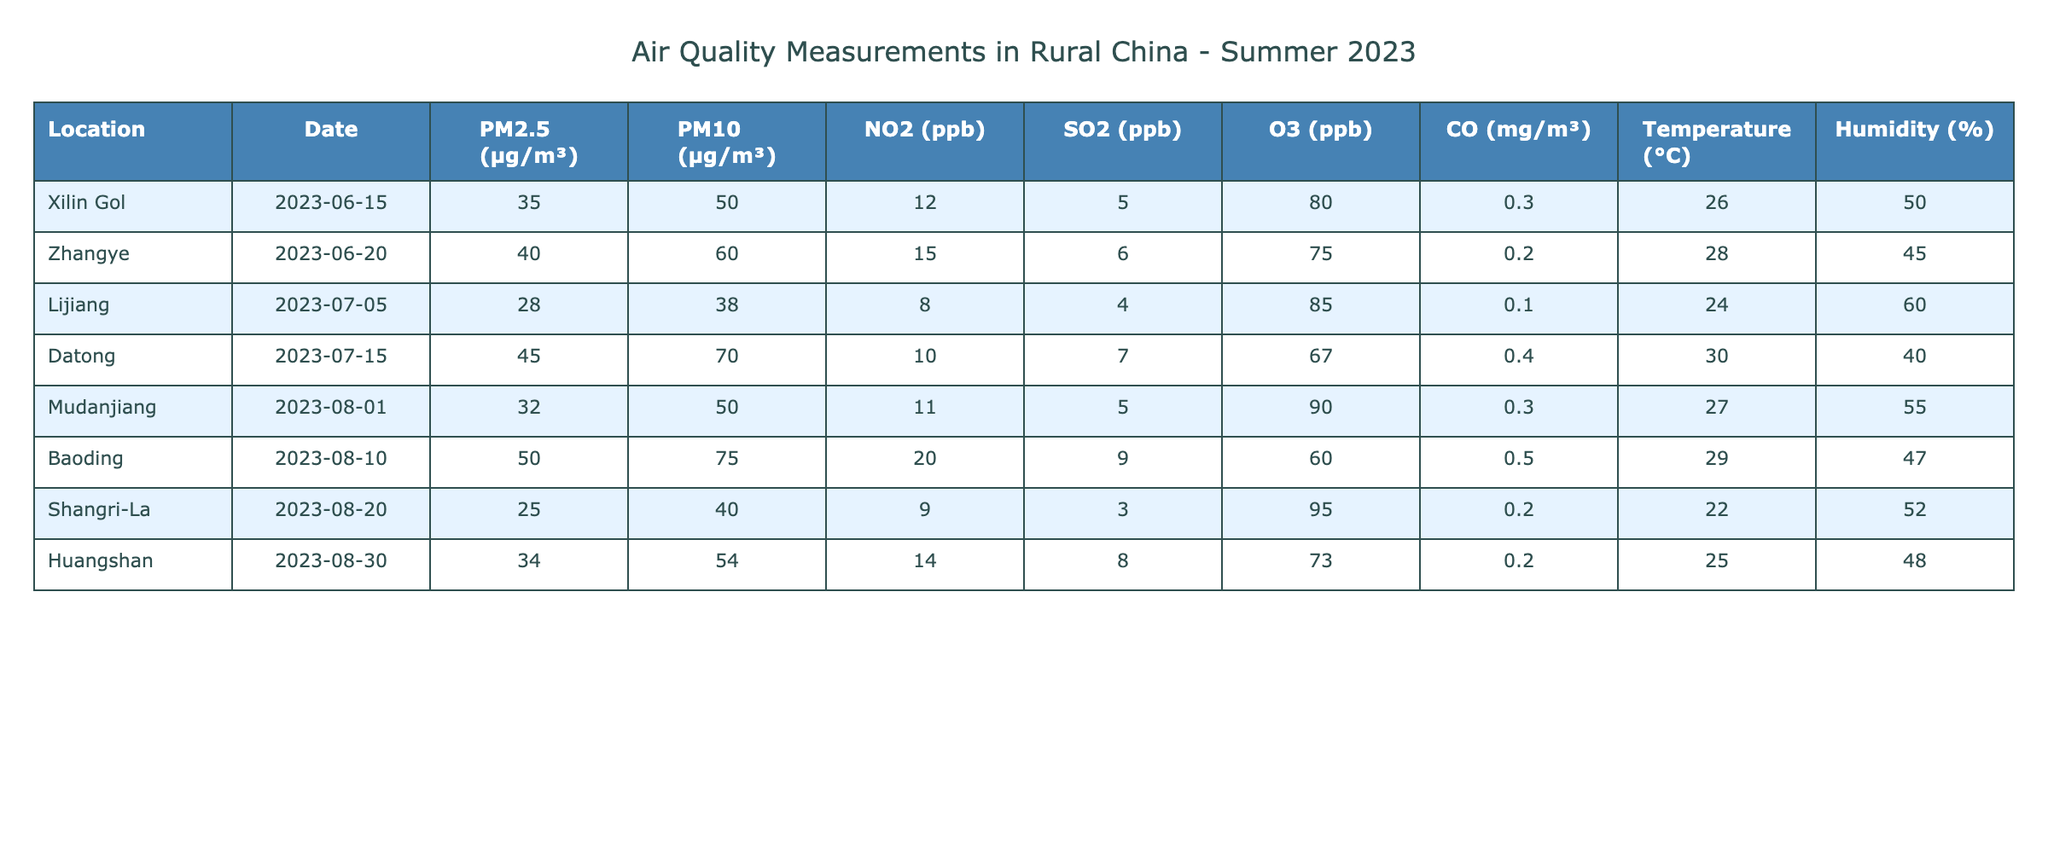What is the PM2.5 level recorded in Baoding on August 10, 2023? The table indicates that Baoding has a PM2.5 level of 50 µg/m³ on the mentioned date. This information is directly referenced in the corresponding row under the PM2.5 column.
Answer: 50 µg/m³ Which location recorded the highest level of NO2? By examining the NO2 values across all locations, Baoding on August 10, 2023, shows the highest level at 20 ppb. This is determined by comparing each NO2 value listed in the table.
Answer: Baoding What is the average SO2 level for the locations listed? The SO2 levels are 5, 6, 4, 7, 5, 9, 3, and 8 for the respective locations. Adding these values gives a total of 43. There are 8 data points, so the average is calculated as 43/8 = 5.375.
Answer: 5.375 ppb Is the humidity level in Zhangye higher than that in Datong? Zhangye's humidity is 45%, while Datong's is 40%. Since 45% is greater than 40%, the statement is true. This is confirmed by comparing respective humidity values in the table.
Answer: Yes What is the difference in PM10 levels between the highest and lowest recorded values? The highest PM10 level is in Baoding with 75 µg/m³, and the lowest is in Lijiang with 38 µg/m³. The difference is calculated as 75 - 38 = 37 µg/m³. Thus, this represents the gap in PM10 levels across locations.
Answer: 37 µg/m³ What is the temperature recorded in Mudanjiang on August 1, 2023? According to the table, Mudanjiang has a temperature of 27°C for the stated date. This can be confirmed directly from the temperature column corresponding to Mudanjiang's row in the table.
Answer: 27°C Which two locations have ozone levels greater than 80 ppb? By examining the O3 column, Xilin Gol has 80 ppb, while all other locations have lower values. Therefore, no locations exceed 80 ppb. This is concluded by reviewing each entry in the O3 column.
Answer: None How does the average PM2.5 level of Xilin Gol and Lijiang compare to that of Baoding? The PM2.5 levels are 35 µg/m³ for Xilin Gol, 28 µg/m³ for Lijiang, and 50 µg/m³ for Baoding. First, we calculate the average for Xilin Gol and Lijiang: (35 + 28)/2 = 31.5 µg/m³. Baoding's level is higher at 50 µg/m³, making it greater than the average of the other two.
Answer: Baoding is higher 